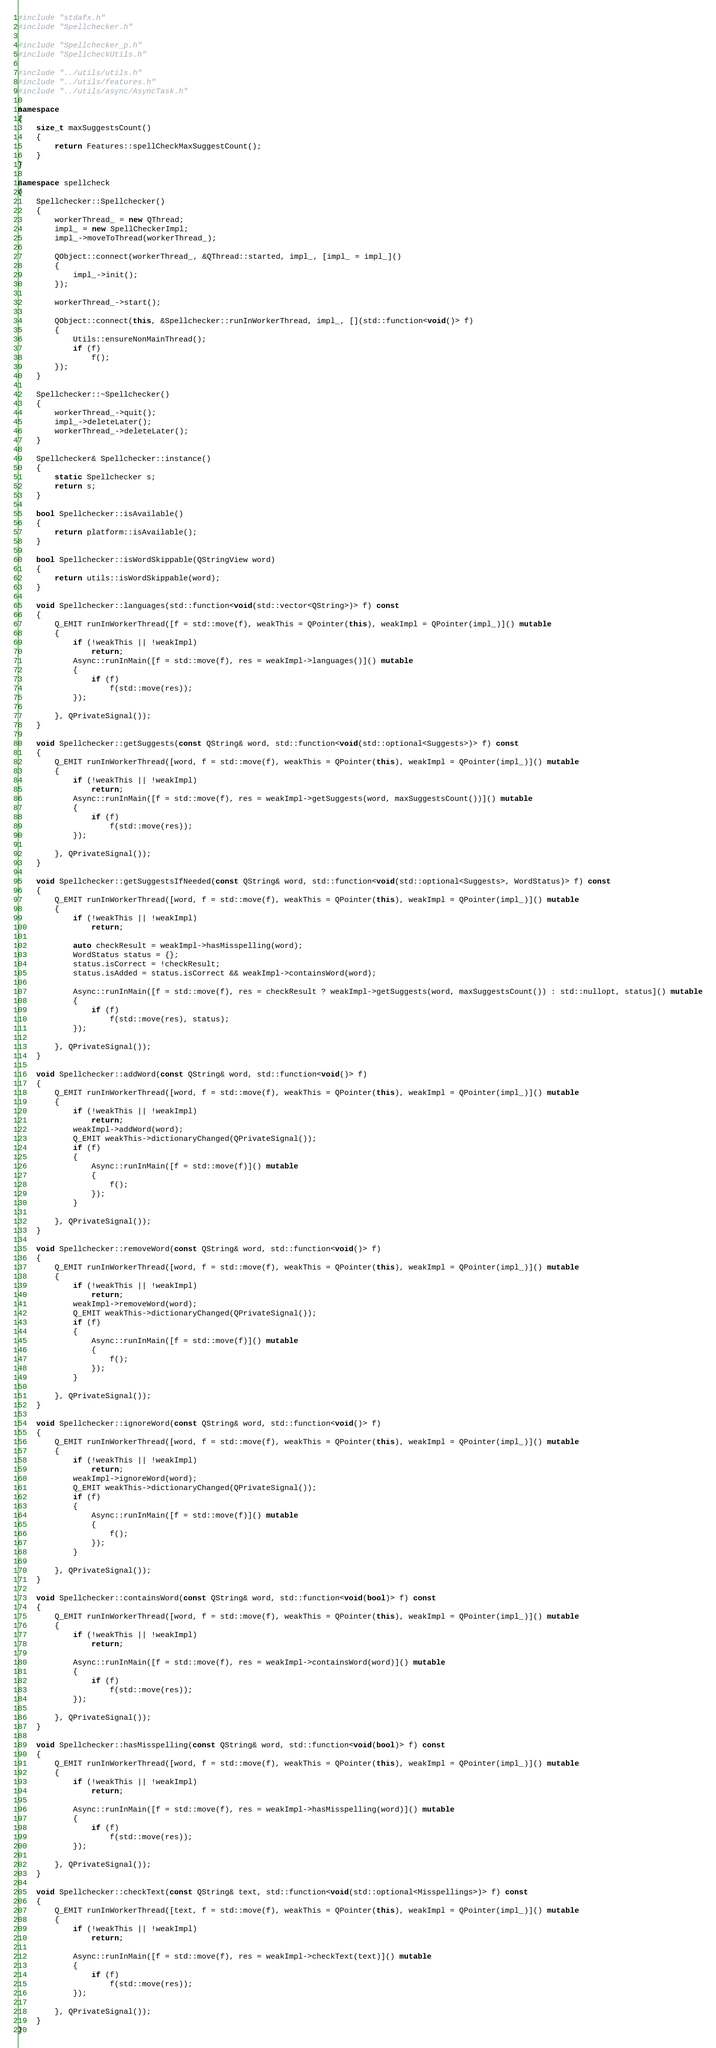Convert code to text. <code><loc_0><loc_0><loc_500><loc_500><_C++_>#include "stdafx.h"
#include "Spellchecker.h"

#include "Spellchecker_p.h"
#include "SpellcheckUtils.h"

#include "../utils/utils.h"
#include "../utils/features.h"
#include "../utils/async/AsyncTask.h"

namespace
{
    size_t maxSuggestsCount()
    {
        return Features::spellCheckMaxSuggestCount();
    }
}

namespace spellcheck
{
    Spellchecker::Spellchecker()
    {
        workerThread_ = new QThread;
        impl_ = new SpellCheckerImpl;
        impl_->moveToThread(workerThread_);

        QObject::connect(workerThread_, &QThread::started, impl_, [impl_ = impl_]()
        {
            impl_->init();
        });

        workerThread_->start();

        QObject::connect(this, &Spellchecker::runInWorkerThread, impl_, [](std::function<void()> f)
        {
            Utils::ensureNonMainThread();
            if (f)
                f();
        });
    }

    Spellchecker::~Spellchecker()
    {
        workerThread_->quit();
        impl_->deleteLater();
        workerThread_->deleteLater();
    }

    Spellchecker& Spellchecker::instance()
    {
        static Spellchecker s;
        return s;
    }

    bool Spellchecker::isAvailable()
    {
        return platform::isAvailable();
    }

    bool Spellchecker::isWordSkippable(QStringView word)
    {
        return utils::isWordSkippable(word);
    }

    void Spellchecker::languages(std::function<void(std::vector<QString>)> f) const
    {
        Q_EMIT runInWorkerThread([f = std::move(f), weakThis = QPointer(this), weakImpl = QPointer(impl_)]() mutable
        {
            if (!weakThis || !weakImpl)
                return;
            Async::runInMain([f = std::move(f), res = weakImpl->languages()]() mutable
            {
                if (f)
                    f(std::move(res));
            });

        }, QPrivateSignal());
    }

    void Spellchecker::getSuggests(const QString& word, std::function<void(std::optional<Suggests>)> f) const
    {
        Q_EMIT runInWorkerThread([word, f = std::move(f), weakThis = QPointer(this), weakImpl = QPointer(impl_)]() mutable
        {
            if (!weakThis || !weakImpl)
                return;
            Async::runInMain([f = std::move(f), res = weakImpl->getSuggests(word, maxSuggestsCount())]() mutable
            {
                if (f)
                    f(std::move(res));
            });

        }, QPrivateSignal());
    }

    void Spellchecker::getSuggestsIfNeeded(const QString& word, std::function<void(std::optional<Suggests>, WordStatus)> f) const
    {
        Q_EMIT runInWorkerThread([word, f = std::move(f), weakThis = QPointer(this), weakImpl = QPointer(impl_)]() mutable
        {
            if (!weakThis || !weakImpl)
                return;

            auto checkResult = weakImpl->hasMisspelling(word);
            WordStatus status = {};
            status.isCorrect = !checkResult;
            status.isAdded = status.isCorrect && weakImpl->containsWord(word);

            Async::runInMain([f = std::move(f), res = checkResult ? weakImpl->getSuggests(word, maxSuggestsCount()) : std::nullopt, status]() mutable
            {
                if (f)
                    f(std::move(res), status);
            });

        }, QPrivateSignal());
    }

    void Spellchecker::addWord(const QString& word, std::function<void()> f)
    {
        Q_EMIT runInWorkerThread([word, f = std::move(f), weakThis = QPointer(this), weakImpl = QPointer(impl_)]() mutable
        {
            if (!weakThis || !weakImpl)
                return;
            weakImpl->addWord(word);
            Q_EMIT weakThis->dictionaryChanged(QPrivateSignal());
            if (f)
            {
                Async::runInMain([f = std::move(f)]() mutable
                {
                    f();
                });
            }

        }, QPrivateSignal());
    }

    void Spellchecker::removeWord(const QString& word, std::function<void()> f)
    {
        Q_EMIT runInWorkerThread([word, f = std::move(f), weakThis = QPointer(this), weakImpl = QPointer(impl_)]() mutable
        {
            if (!weakThis || !weakImpl)
                return;
            weakImpl->removeWord(word);
            Q_EMIT weakThis->dictionaryChanged(QPrivateSignal());
            if (f)
            {
                Async::runInMain([f = std::move(f)]() mutable
                {
                    f();
                });
            }

        }, QPrivateSignal());
    }

    void Spellchecker::ignoreWord(const QString& word, std::function<void()> f)
    {
        Q_EMIT runInWorkerThread([word, f = std::move(f), weakThis = QPointer(this), weakImpl = QPointer(impl_)]() mutable
        {
            if (!weakThis || !weakImpl)
                return;
            weakImpl->ignoreWord(word);
            Q_EMIT weakThis->dictionaryChanged(QPrivateSignal());
            if (f)
            {
                Async::runInMain([f = std::move(f)]() mutable
                {
                    f();
                });
            }

        }, QPrivateSignal());
    }

    void Spellchecker::containsWord(const QString& word, std::function<void(bool)> f) const
    {
        Q_EMIT runInWorkerThread([word, f = std::move(f), weakThis = QPointer(this), weakImpl = QPointer(impl_)]() mutable
        {
            if (!weakThis || !weakImpl)
                return;

            Async::runInMain([f = std::move(f), res = weakImpl->containsWord(word)]() mutable
            {
                if (f)
                    f(std::move(res));
            });

        }, QPrivateSignal());
    }

    void Spellchecker::hasMisspelling(const QString& word, std::function<void(bool)> f) const
    {
        Q_EMIT runInWorkerThread([word, f = std::move(f), weakThis = QPointer(this), weakImpl = QPointer(impl_)]() mutable
        {
            if (!weakThis || !weakImpl)
                return;

            Async::runInMain([f = std::move(f), res = weakImpl->hasMisspelling(word)]() mutable
            {
                if (f)
                    f(std::move(res));
            });

        }, QPrivateSignal());
    }

    void Spellchecker::checkText(const QString& text, std::function<void(std::optional<Misspellings>)> f) const
    {
        Q_EMIT runInWorkerThread([text, f = std::move(f), weakThis = QPointer(this), weakImpl = QPointer(impl_)]() mutable
        {
            if (!weakThis || !weakImpl)
                return;

            Async::runInMain([f = std::move(f), res = weakImpl->checkText(text)]() mutable
            {
                if (f)
                    f(std::move(res));
            });

        }, QPrivateSignal());
    }
}
</code> 